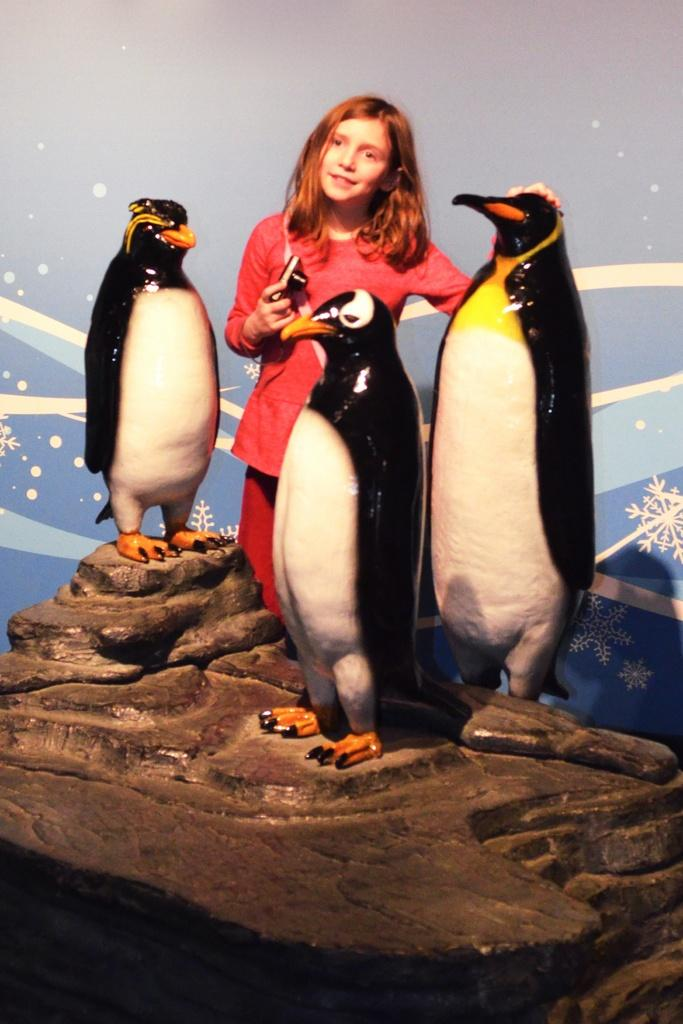What animals are shown on a rock in the image? There are penguins depicted on a rock in the image. Who else is present in the image besides the penguins? There is a girl in the image. What type of fear does the girl express while attending the party in the image? There is no party depicted in the image, and the girl's emotions or fears cannot be determined from the image. 